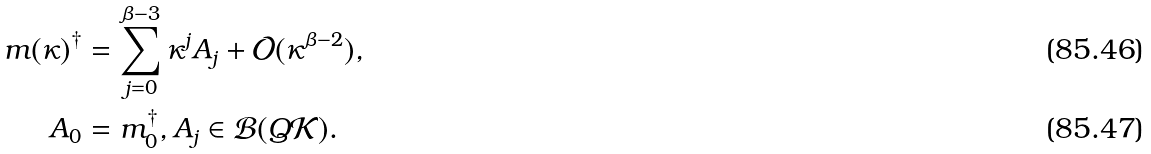<formula> <loc_0><loc_0><loc_500><loc_500>m ( \kappa ) ^ { \dagger } & = \sum _ { j = 0 } ^ { \beta - 3 } \kappa ^ { j } A _ { j } + \mathcal { O } ( \kappa ^ { \beta - 2 } ) , \\ A _ { 0 } & = m _ { 0 } ^ { \dagger } , A _ { j } \in \mathcal { B } ( Q \mathcal { K } ) .</formula> 